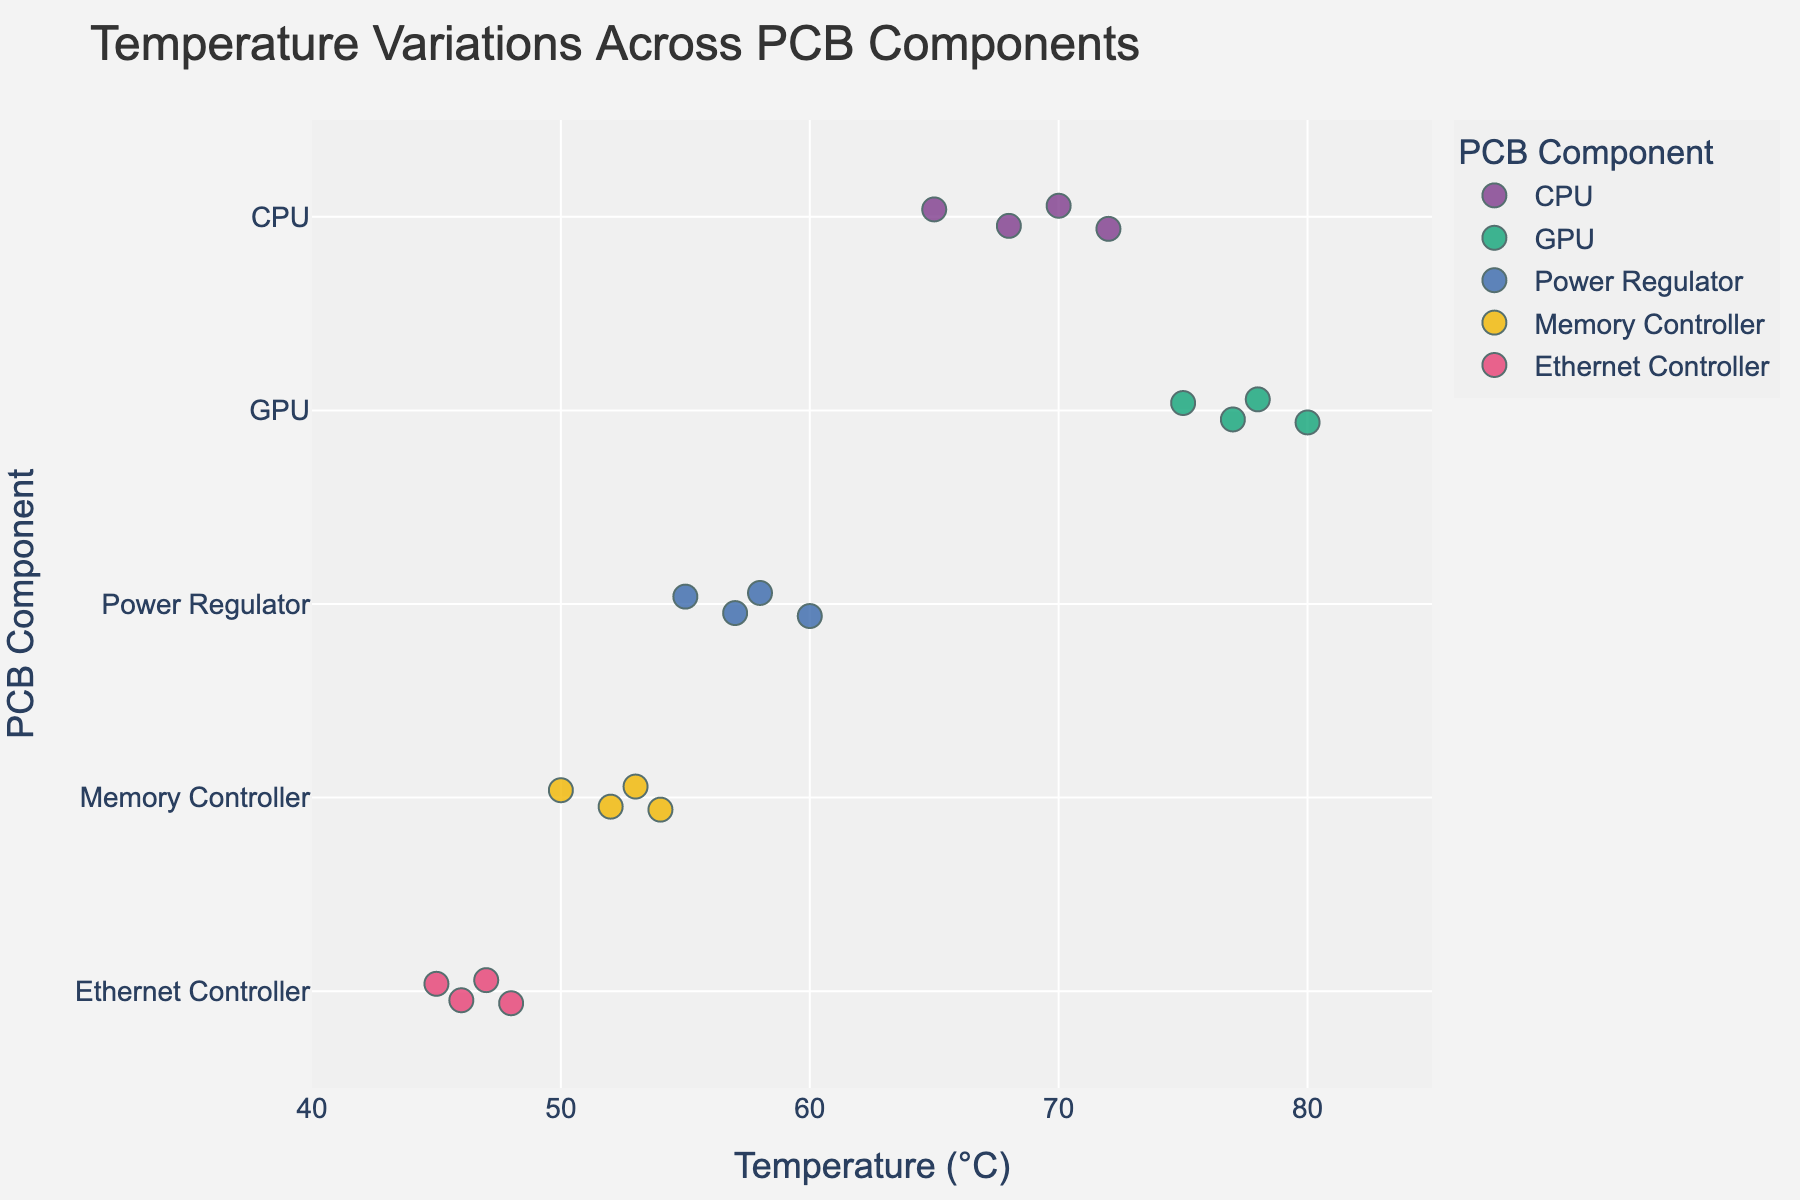How many data points are plotted for the GPU component? Visual examination of the figure shows the number of points aligned with the GPU label on the y-axis
Answer: 4 What is the range of temperatures recorded for the CPU? The temperature points for the CPU on the figure are from 65°C to 72°C
Answer: 65°C to 72°C Which component has the highest temperature recorded? According to the plot, the highest temperatures are marked next to their corresponding components, with the GPU having the peak at 80°C
Answer: GPU Compare the average temperatures of the Power Regulator and the Memory Controller. Which one is higher? Calculate the average temperatures: Power Regulator (55+58+60+57)/4 = 57.5°C, Memory Controller (50+52+54+53)/4 = 52.25°C. Compare the results
Answer: Power Regulator Are there any components with overlapping temperature ranges? By examining the temperature ranges across all components on the figure, we see that the temperature ranges for all components overlap somewhat, except the Ethernet Controller, which is generally lower.
Answer: Yes What is the most common temperature recorded for the Ethernet Controller? Identify the temperatures and their frequencies; the temperature 46°C appears twice for the Ethernet Controller
Answer: 46°C Between the CPU and the Memory Controller, which has a wider range of temperature variations? The CPU's temperatures vary from 65°C to 72°C (a range of 7°C). Memory Controller's temperatures vary from 50°C to 54°C (a range of 4°C)
Answer: CPU Which component shows the lowest temperature in the figure? The lowest temperature observed across all components is 45°C associated with the Ethernet Controller
Answer: Ethernet Controller How does the median temperature of the GPU compare to the median temperature of the Power Regulator? Median for GPU: (75, 77, 78, 80 -> Median = (77+78)/2 = 77.5°C). Median for Power Regulator: (55, 57, 58, 60 -> Median = (57+58)/2 = 57.5°C)
Answer: GPU's median is higher What is the temperature difference between the highest and lowest recorded values of all components? The highest recorded temperature is 80°C and the lowest is 45°C. Their difference is 80 - 45
Answer: 35°C 